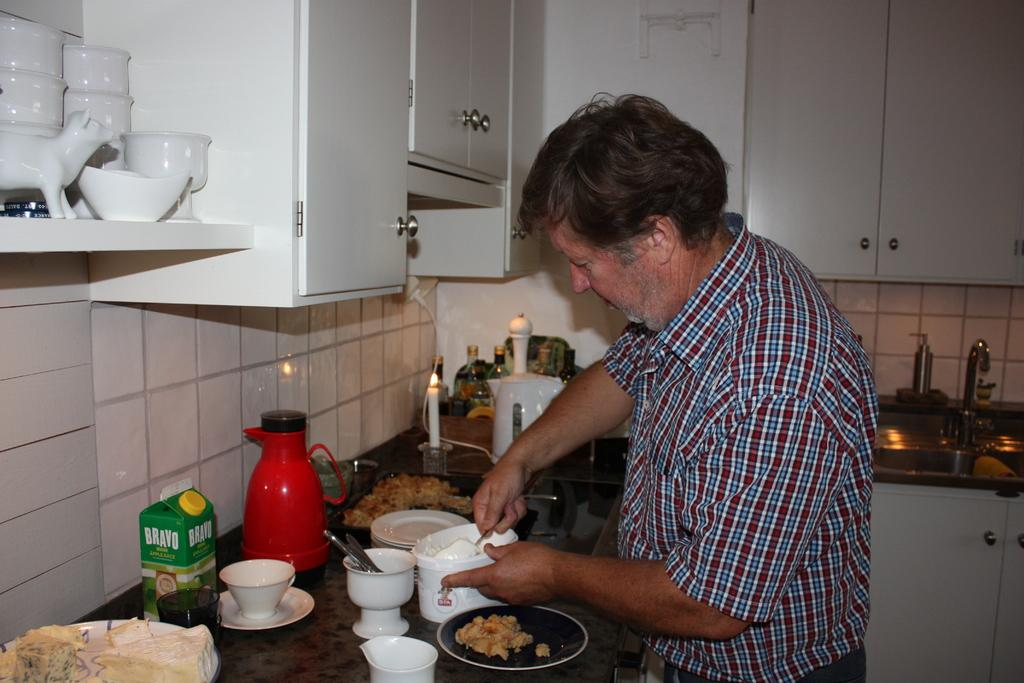Provide a one-sentence caption for the provided image. A man cooking in a kitchen where a green BRAVO carton box nearby. 